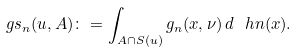<formula> <loc_0><loc_0><loc_500><loc_500>\ g s _ { n } ( u , A ) \colon = \int _ { A \cap S ( u ) } g _ { n } ( x , \nu ) \, d \ h n ( x ) .</formula> 